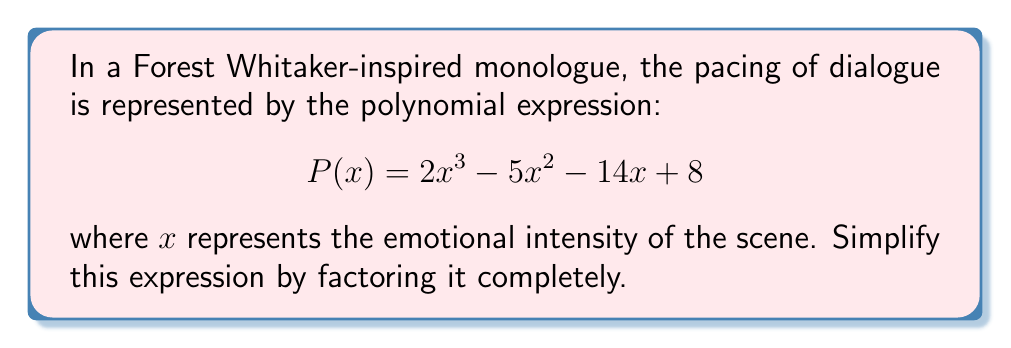Teach me how to tackle this problem. To factor this polynomial completely, we'll follow these steps:

1) First, let's check if there's a common factor:
   There is no common factor for all terms.

2) This is a cubic polynomial, so we'll try to find a root using the rational root theorem. The possible rational roots are the factors of the constant term: ±1, ±2, ±4, ±8.

3) Testing these values, we find that P(1) = 0, so (x - 1) is a factor.

4) Divide P(x) by (x - 1) using polynomial long division:

   $$ 2x^3 - 5x^2 - 14x + 8 = (x - 1)(2x^2 - 3x - 8) $$

5) Now we need to factor the quadratic term $2x^2 - 3x - 8$:
   
   a) The product of the first and last terms is -16.
   b) We need to find two numbers that multiply to give -16 and add to give -3.
   c) These numbers are -5 and 2.

6) So, we can rewrite the quadratic as:

   $$ 2x^2 - 3x - 8 = 2x^2 - 5x + 2x - 8 = x(2x - 5) + 2(x - 4) $$

7) Factoring out the greatest common factor:

   $$ 2x^2 - 3x - 8 = (x + 2)(2x - 4) = (x + 2)(2)(x - 2) $$

8) Therefore, the complete factorization is:

   $$ P(x) = (x - 1)(x + 2)(2)(x - 2) = 2(x - 1)(x + 2)(x - 2) $$

This factorization represents the emotional peaks and valleys in the monologue, with x = 1, x = -2, and x = 2 being critical points in the delivery.
Answer: $$ P(x) = 2(x - 1)(x + 2)(x - 2) $$ 